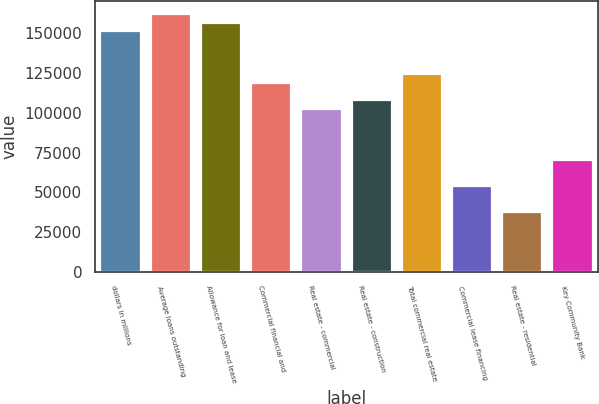Convert chart to OTSL. <chart><loc_0><loc_0><loc_500><loc_500><bar_chart><fcel>dollars in millions<fcel>Average loans outstanding<fcel>Allowance for loan and lease<fcel>Commercial financial and<fcel>Real estate - commercial<fcel>Real estate - construction<fcel>Total commercial real estate<fcel>Commercial lease financing<fcel>Real estate - residential<fcel>Key Community Bank<nl><fcel>151115<fcel>161909<fcel>156512<fcel>118734<fcel>102543<fcel>107940<fcel>124131<fcel>53971<fcel>37780.3<fcel>70161.7<nl></chart> 